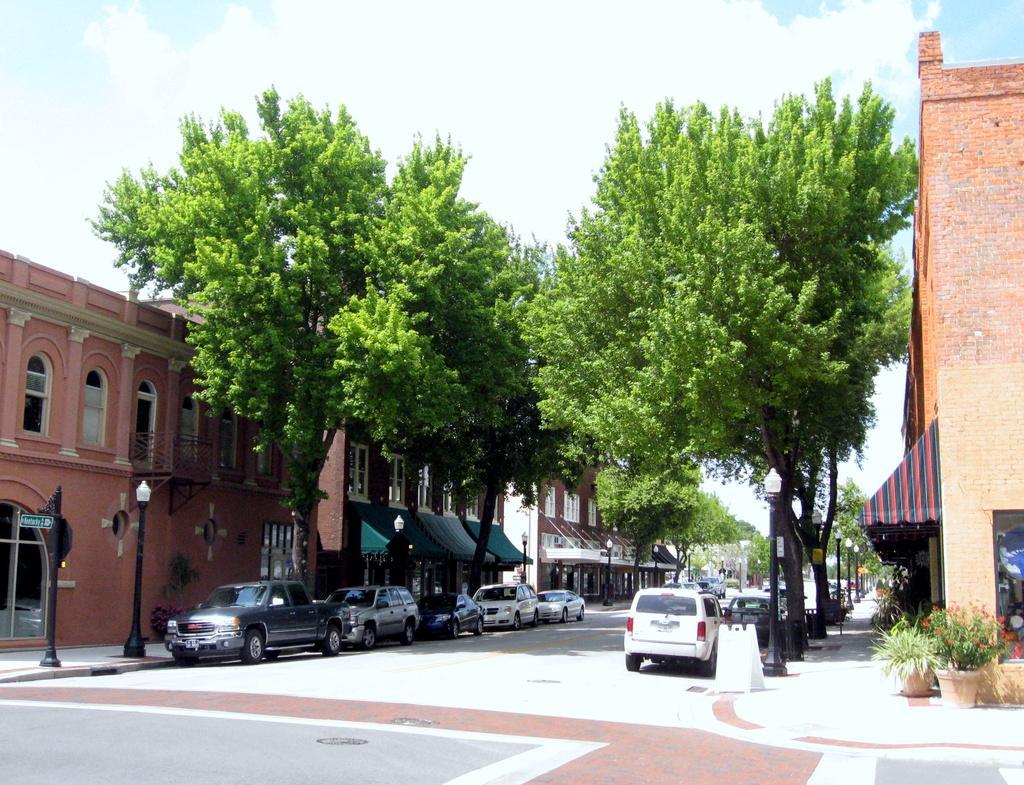Please provide a concise description of this image. In this image in the center there are some vehicles, and there are some tents railing. And on the right side and left side there are buildings, trees, poles and lights and also there are flower pots and plants. At the bottom there is road and at the top there is sky. 